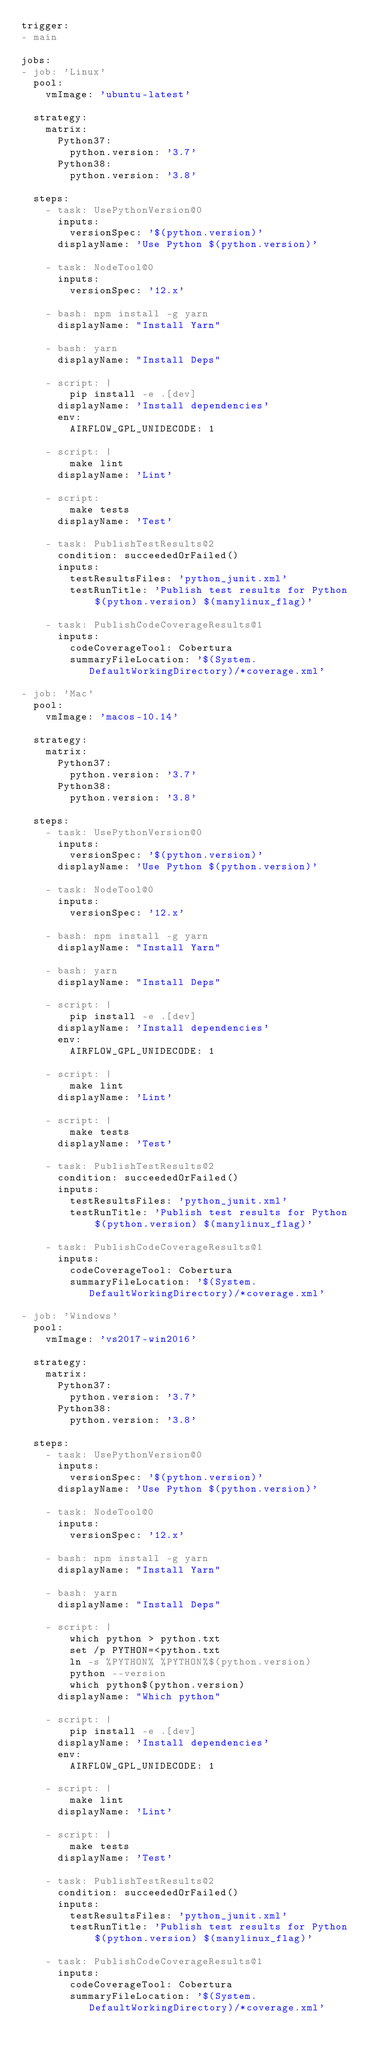Convert code to text. <code><loc_0><loc_0><loc_500><loc_500><_YAML_>trigger:
- main

jobs:
- job: 'Linux'
  pool:
    vmImage: 'ubuntu-latest'

  strategy:
    matrix:
      Python37:
        python.version: '3.7'
      Python38:
        python.version: '3.8'

  steps:
    - task: UsePythonVersion@0
      inputs:
        versionSpec: '$(python.version)'
      displayName: 'Use Python $(python.version)'

    - task: NodeTool@0
      inputs:
        versionSpec: '12.x'

    - bash: npm install -g yarn
      displayName: "Install Yarn"

    - bash: yarn
      displayName: "Install Deps"

    - script: |
        pip install -e .[dev]
      displayName: 'Install dependencies'
      env:
        AIRFLOW_GPL_UNIDECODE: 1

    - script: |
        make lint
      displayName: 'Lint'

    - script:
        make tests
      displayName: 'Test'

    - task: PublishTestResults@2
      condition: succeededOrFailed()
      inputs:
        testResultsFiles: 'python_junit.xml'
        testRunTitle: 'Publish test results for Python $(python.version) $(manylinux_flag)'

    - task: PublishCodeCoverageResults@1
      inputs: 
        codeCoverageTool: Cobertura
        summaryFileLocation: '$(System.DefaultWorkingDirectory)/*coverage.xml'

- job: 'Mac'
  pool:
    vmImage: 'macos-10.14'

  strategy:
    matrix:
      Python37:
        python.version: '3.7'
      Python38:
        python.version: '3.8'
  
  steps:
    - task: UsePythonVersion@0
      inputs:
        versionSpec: '$(python.version)'
      displayName: 'Use Python $(python.version)'

    - task: NodeTool@0
      inputs:
        versionSpec: '12.x'

    - bash: npm install -g yarn
      displayName: "Install Yarn"

    - bash: yarn
      displayName: "Install Deps"

    - script: |
        pip install -e .[dev]
      displayName: 'Install dependencies'
      env:
        AIRFLOW_GPL_UNIDECODE: 1

    - script: |
        make lint
      displayName: 'Lint'

    - script: |
        make tests
      displayName: 'Test'

    - task: PublishTestResults@2
      condition: succeededOrFailed()
      inputs:
        testResultsFiles: 'python_junit.xml'
        testRunTitle: 'Publish test results for Python $(python.version) $(manylinux_flag)'

    - task: PublishCodeCoverageResults@1
      inputs: 
        codeCoverageTool: Cobertura
        summaryFileLocation: '$(System.DefaultWorkingDirectory)/*coverage.xml'

- job: 'Windows'
  pool:
    vmImage: 'vs2017-win2016'

  strategy:
    matrix:
      Python37:
        python.version: '3.7'
      Python38:
        python.version: '3.8'
  
  steps:
    - task: UsePythonVersion@0
      inputs:
        versionSpec: '$(python.version)'
      displayName: 'Use Python $(python.version)'

    - task: NodeTool@0
      inputs:
        versionSpec: '12.x'

    - bash: npm install -g yarn
      displayName: "Install Yarn"

    - bash: yarn
      displayName: "Install Deps"

    - script: |
        which python > python.txt
        set /p PYTHON=<python.txt
        ln -s %PYTHON% %PYTHON%$(python.version)
        python --version
        which python$(python.version)
      displayName: "Which python"

    - script: |
        pip install -e .[dev]
      displayName: 'Install dependencies'
      env:
        AIRFLOW_GPL_UNIDECODE: 1

    - script: |
        make lint
      displayName: 'Lint'

    - script: |
        make tests
      displayName: 'Test'

    - task: PublishTestResults@2
      condition: succeededOrFailed()
      inputs:
        testResultsFiles: 'python_junit.xml'
        testRunTitle: 'Publish test results for Python $(python.version) $(manylinux_flag)'

    - task: PublishCodeCoverageResults@1
      inputs: 
        codeCoverageTool: Cobertura
        summaryFileLocation: '$(System.DefaultWorkingDirectory)/*coverage.xml'
</code> 